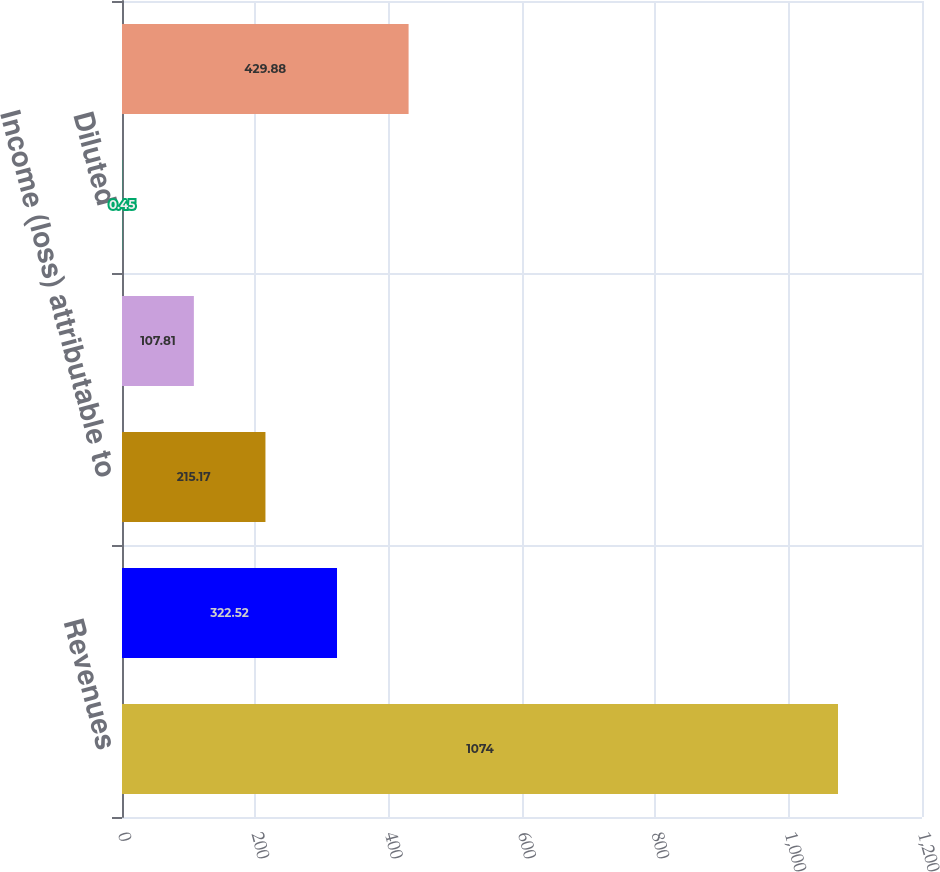Convert chart. <chart><loc_0><loc_0><loc_500><loc_500><bar_chart><fcel>Revenues<fcel>Operating income (loss)<fcel>Income (loss) attributable to<fcel>Basic<fcel>Diluted<fcel>Net income (loss)<nl><fcel>1074<fcel>322.52<fcel>215.17<fcel>107.81<fcel>0.45<fcel>429.88<nl></chart> 